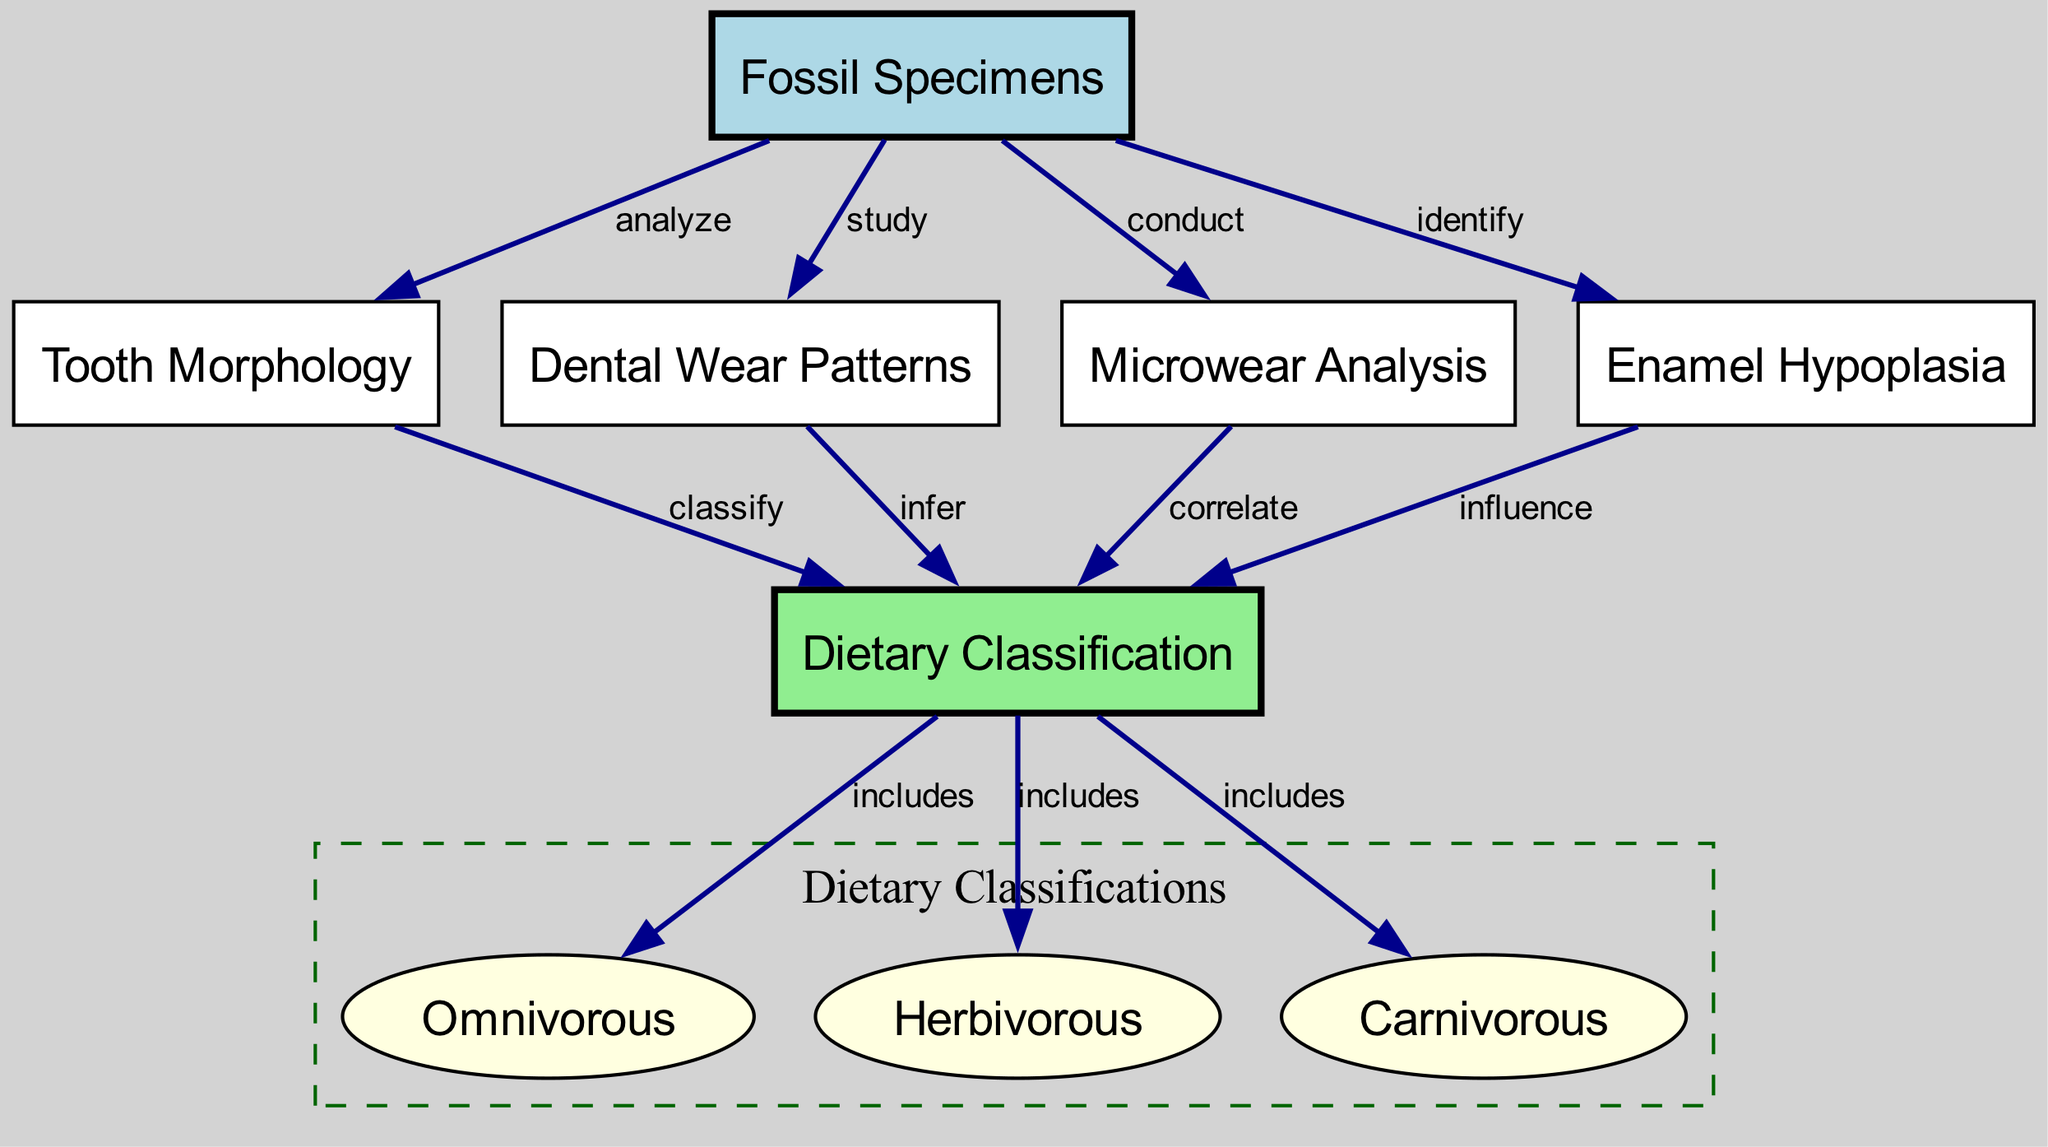What nodes are present in the diagram? The diagram features various nodes such as 'Fossil Specimens', 'Tooth Morphology', 'Dental Wear Patterns', 'Microwear Analysis', 'Enamel Hypoplasia', and 'Dietary Classification', among others, which represent key components in the analysis of fossilized dental structures.
Answer: Fossil Specimens, Tooth Morphology, Dental Wear Patterns, Microwear Analysis, Enamel Hypoplasia, Dietary Classification What type of dietary classifications are included in the diagram? The diagram categorizes three types of dietary classifications under 'Dietary Classification': 'Omnivorous', 'Herbivorous', and 'Carnivorous', indicating the variety of diets inferred from the fossilized dental structures.
Answer: Omnivorous, Herbivorous, Carnivorous How many edges connect 'Fossil Specimens' to other nodes? The 'Fossil Specimens' node is connected to four other nodes: 'Tooth Morphology', 'Dental Wear Patterns', 'Microwear Analysis', and 'Enamel Hypoplasia', making a total of four edges stemming from it.
Answer: 4 What does the 'Microwear Analysis' node correlate with? The 'Microwear Analysis' node primarily correlates with the 'Dietary Classification' node, indicating its significance in determining various dietary patterns of the fossilized specimens through detailed analysis of wear on teeth.
Answer: Dietary Classification Which node influences the 'Dietary Classification'? The 'Enamel Hypoplasia' node influences the 'Dietary Classification' node, suggesting that abnormalities in enamel can provide insights into the dietary habits and nutritional stress of the organism.
Answer: Enamel Hypoplasia How are 'Dental Wear Patterns' related to dietary classifications? 'Dental Wear Patterns' are used to infer the type of dietary classification an organism had, establishing a direct relationship between the wear observed on teeth and the diet consumed.
Answer: Infer What is the significance of 'Tooth Morphology' in determining diets? The 'Tooth Morphology' node is important as it classifies the fossil specimens based on the structure of their teeth, which helps in identifying the dietary habits of the organism, directly linking morphology to diet classification.
Answer: Classify What can 'Dental Wear Patterns' tell us about fossil specimens? 'Dental Wear Patterns' provide insights into the feeding behavior and diet of fossil specimens, indicating how different foods may impact the wear observed on their teeth, which is crucial for diet analysis.
Answer: Insights into feeding behavior How does 'Enamel Hypoplasia' relate to dietary analysis? 'Enamel Hypoplasia' is identified from the fossil specimens and its assessment can influence the understanding of dietary classification, particularly regarding nutritional deficiencies faced by the organism.
Answer: Influence the understanding of dietary classification 